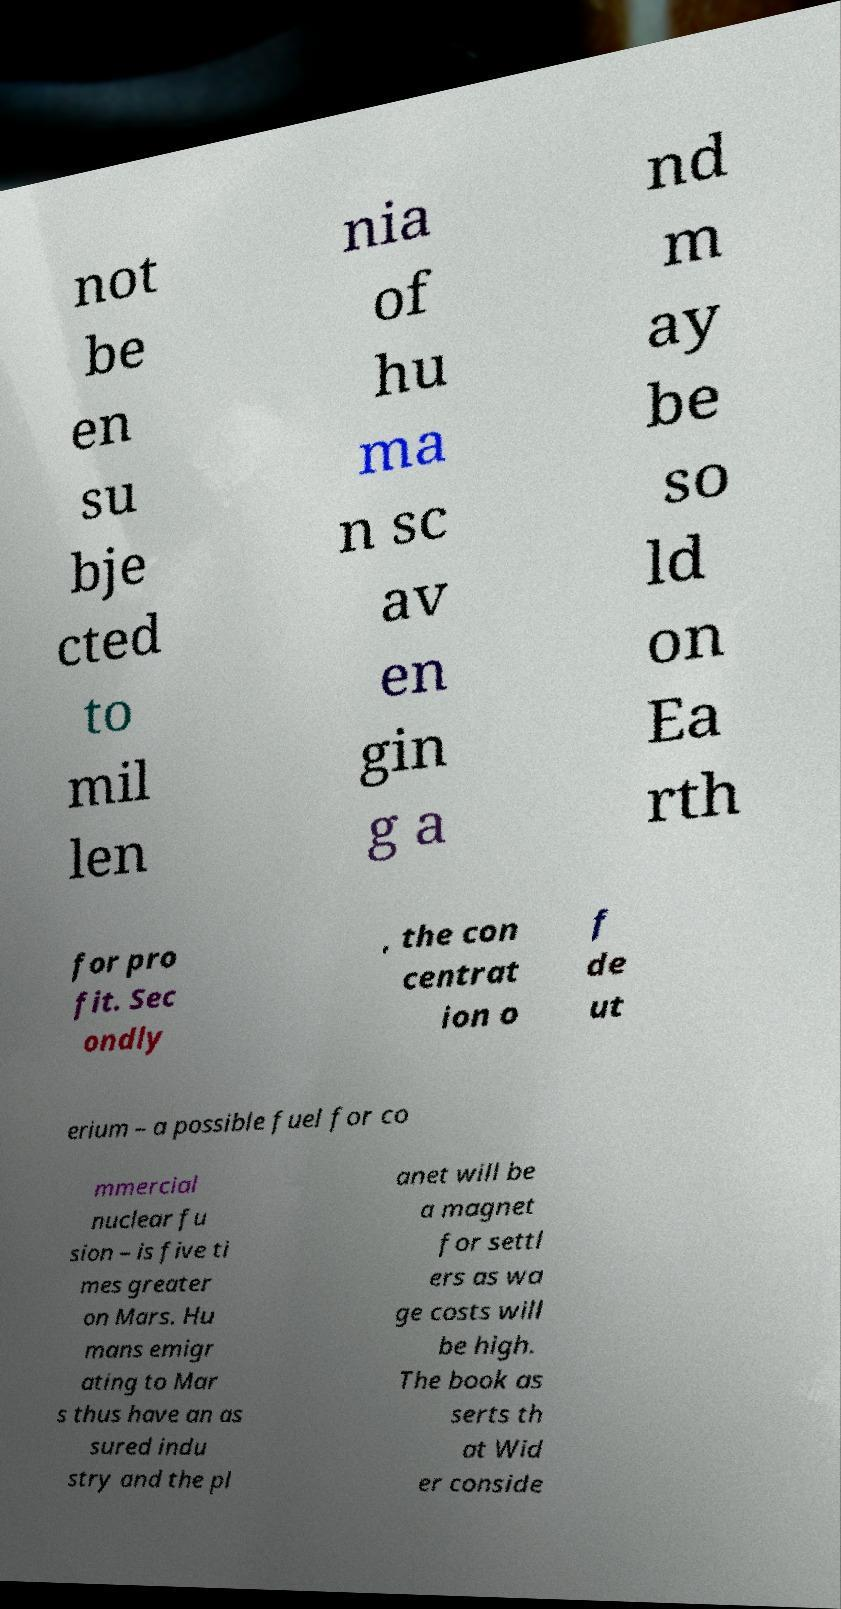Could you assist in decoding the text presented in this image and type it out clearly? not be en su bje cted to mil len nia of hu ma n sc av en gin g a nd m ay be so ld on Ea rth for pro fit. Sec ondly , the con centrat ion o f de ut erium – a possible fuel for co mmercial nuclear fu sion – is five ti mes greater on Mars. Hu mans emigr ating to Mar s thus have an as sured indu stry and the pl anet will be a magnet for settl ers as wa ge costs will be high. The book as serts th at Wid er conside 